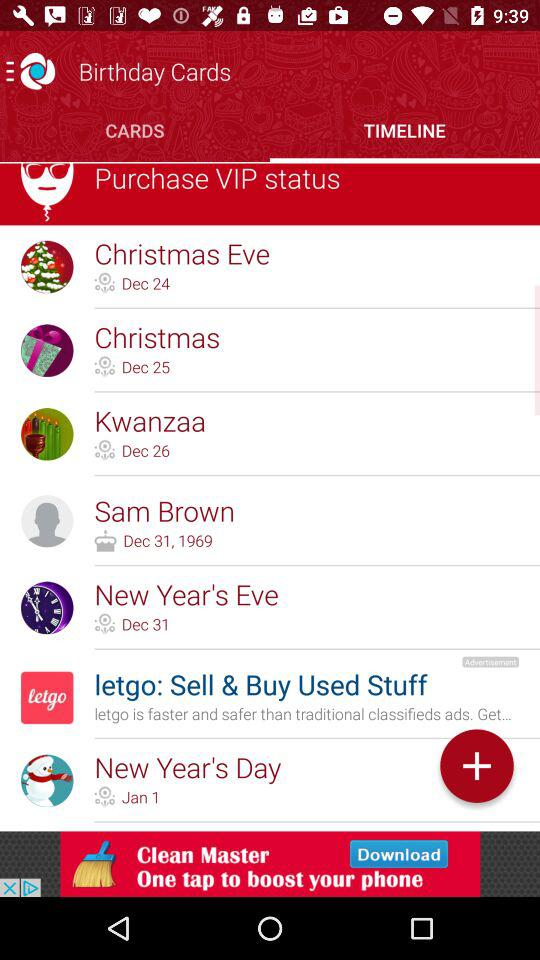What is the Christmas Eve date? The Christmas Eve date is December 24. 